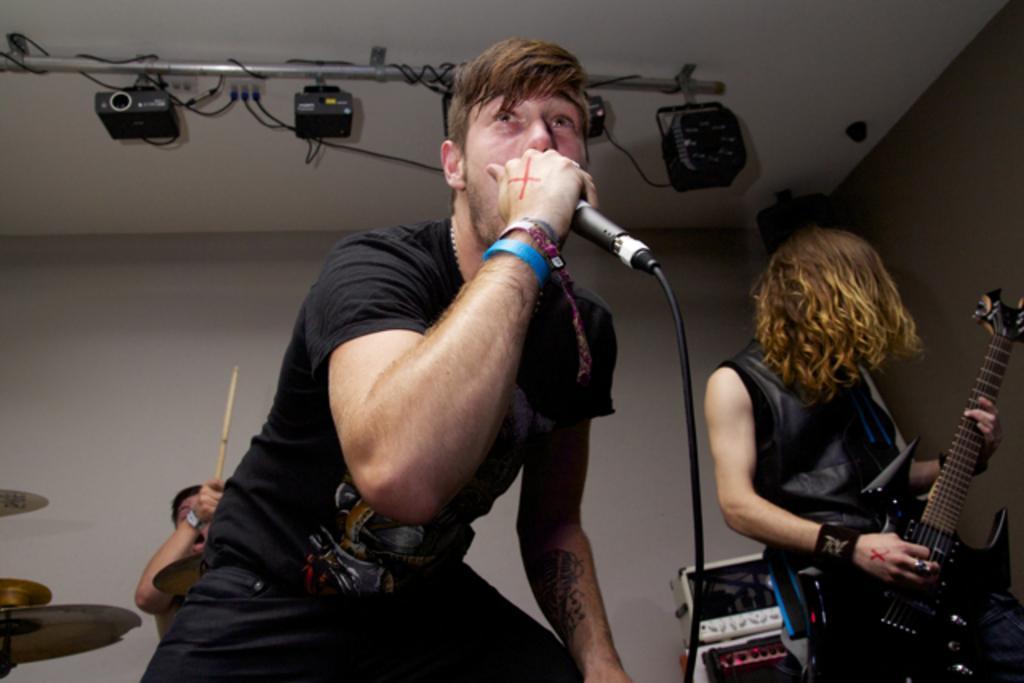Please provide a concise description of this image. In this picture there is a man standing at the center of holding a microphone, another man on the right holding a guitar in another man in the back side there is a man holding a the drumstick and is a projector attached to the ceiling 